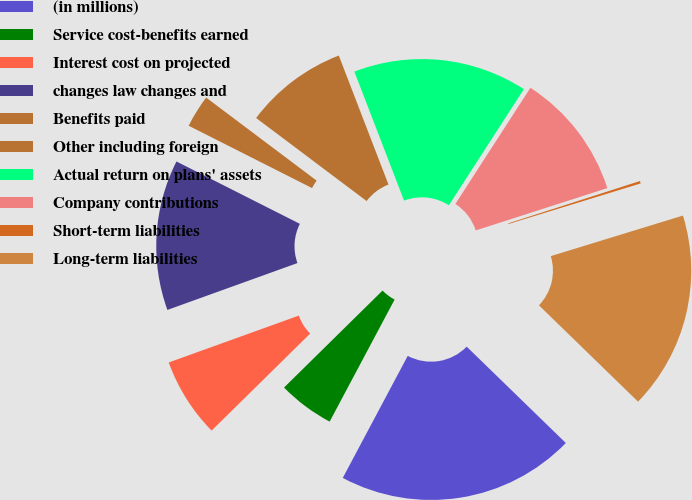<chart> <loc_0><loc_0><loc_500><loc_500><pie_chart><fcel>(in millions)<fcel>Service cost-benefits earned<fcel>Interest cost on projected<fcel>changes law changes and<fcel>Benefits paid<fcel>Other including foreign<fcel>Actual return on plans' assets<fcel>Company contributions<fcel>Short-term liabilities<fcel>Long-term liabilities<nl><fcel>20.51%<fcel>4.84%<fcel>6.87%<fcel>12.95%<fcel>2.81%<fcel>8.89%<fcel>14.98%<fcel>10.92%<fcel>0.21%<fcel>17.01%<nl></chart> 